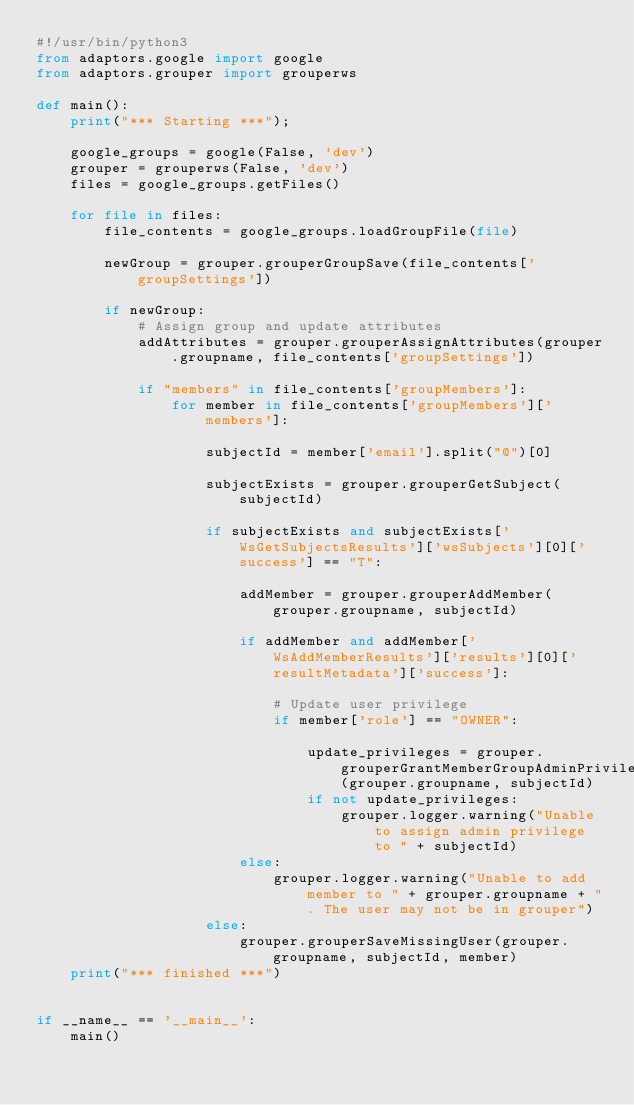<code> <loc_0><loc_0><loc_500><loc_500><_Python_>#!/usr/bin/python3
from adaptors.google import google
from adaptors.grouper import grouperws

def main():
    print("*** Starting ***");

    google_groups = google(False, 'dev')
    grouper = grouperws(False, 'dev')
    files = google_groups.getFiles()

    for file in files:
        file_contents = google_groups.loadGroupFile(file)

        newGroup = grouper.grouperGroupSave(file_contents['groupSettings'])

        if newGroup:
            # Assign group and update attributes
            addAttributes = grouper.grouperAssignAttributes(grouper.groupname, file_contents['groupSettings'])

            if "members" in file_contents['groupMembers']:
                for member in file_contents['groupMembers']['members']:

                    subjectId = member['email'].split("@")[0]

                    subjectExists = grouper.grouperGetSubject(subjectId)

                    if subjectExists and subjectExists['WsGetSubjectsResults']['wsSubjects'][0]['success'] == "T":

                        addMember = grouper.grouperAddMember(grouper.groupname, subjectId)

                        if addMember and addMember['WsAddMemberResults']['results'][0]['resultMetadata']['success']:

                            # Update user privilege
                            if member['role'] == "OWNER":

                                update_privileges = grouper.grouperGrantMemberGroupAdminPrivilege(grouper.groupname, subjectId)
                                if not update_privileges:
                                    grouper.logger.warning("Unable to assign admin privilege to " + subjectId)
                        else:
                            grouper.logger.warning("Unable to add member to " + grouper.groupname + ". The user may not be in grouper")
                    else:
                        grouper.grouperSaveMissingUser(grouper.groupname, subjectId, member)
    print("*** finished ***")


if __name__ == '__main__':
    main()</code> 